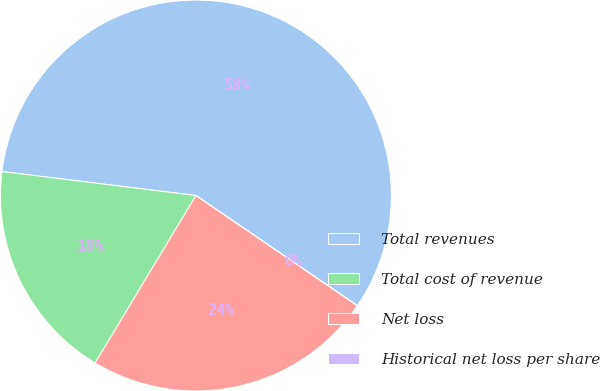Convert chart to OTSL. <chart><loc_0><loc_0><loc_500><loc_500><pie_chart><fcel>Total revenues<fcel>Total cost of revenue<fcel>Net loss<fcel>Historical net loss per share<nl><fcel>57.58%<fcel>18.33%<fcel>24.09%<fcel>0.0%<nl></chart> 